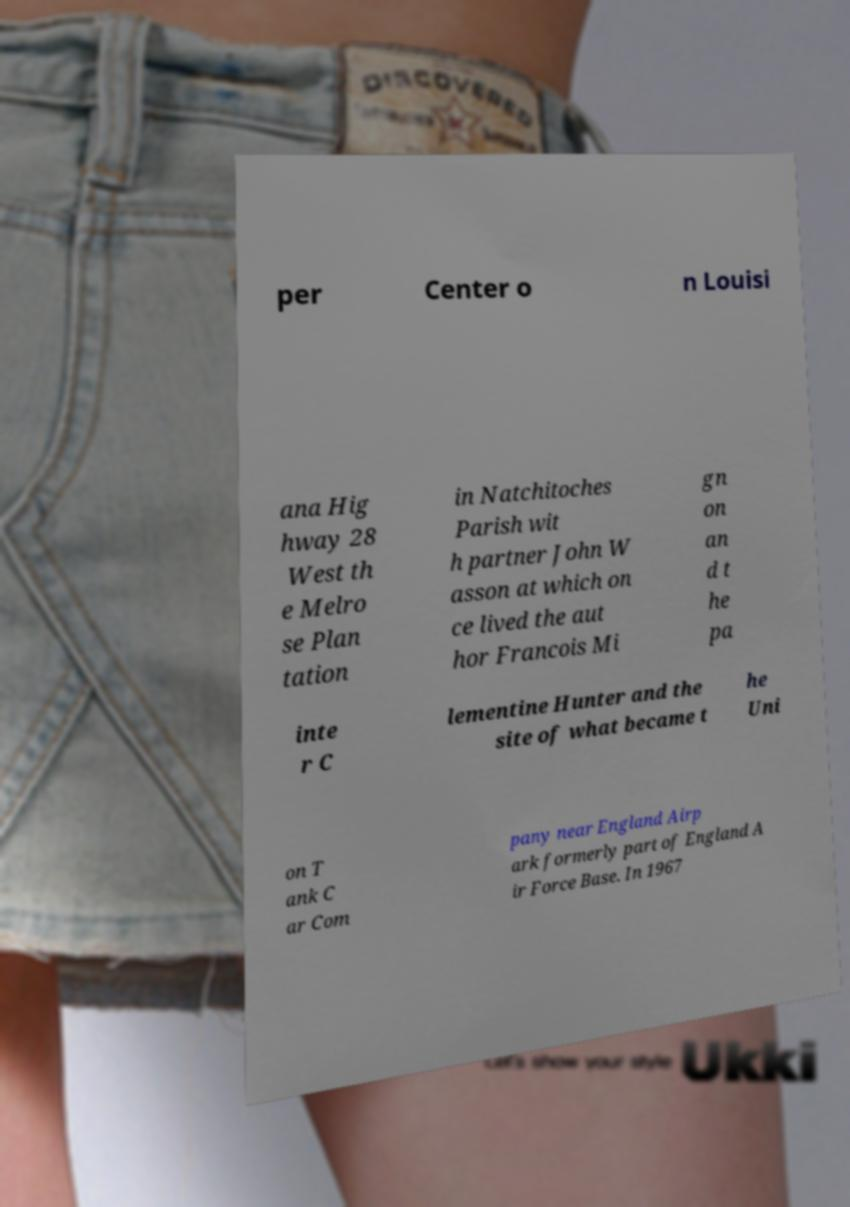Can you read and provide the text displayed in the image?This photo seems to have some interesting text. Can you extract and type it out for me? per Center o n Louisi ana Hig hway 28 West th e Melro se Plan tation in Natchitoches Parish wit h partner John W asson at which on ce lived the aut hor Francois Mi gn on an d t he pa inte r C lementine Hunter and the site of what became t he Uni on T ank C ar Com pany near England Airp ark formerly part of England A ir Force Base. In 1967 